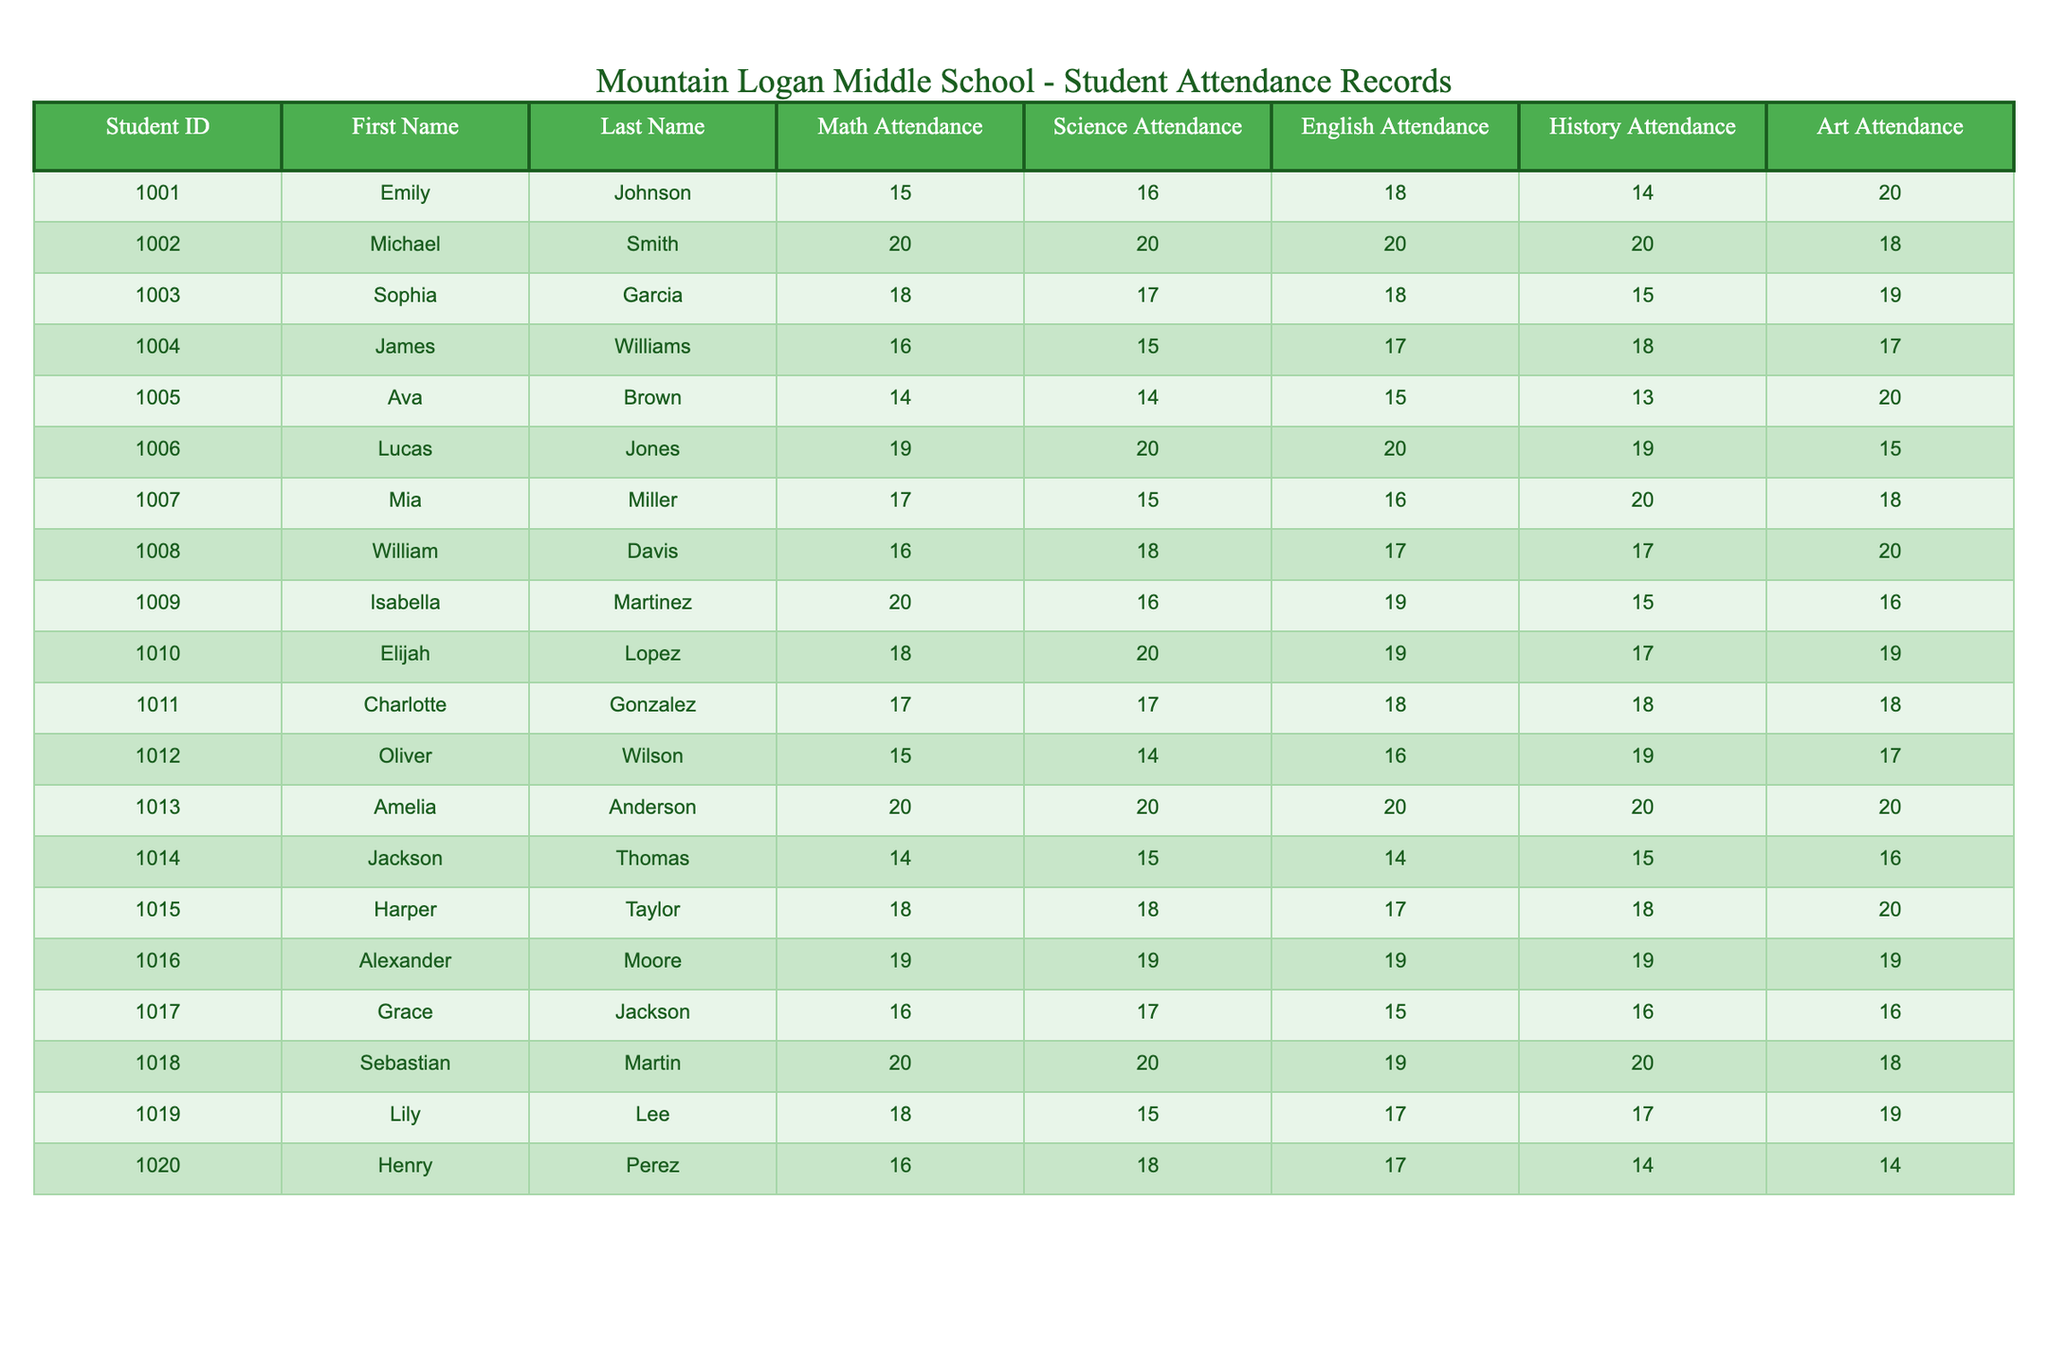What is the total attendance of Emily Johnson in all subjects? Emily Johnson's attendance in Math is 15, Science is 16, English is 18, History is 14, and Art is 20. Adding these values together gives us 15 + 16 + 18 + 14 + 20 = 83.
Answer: 83 Which student has the highest attendance in Art? By examining the Art Attendance column, we see the following values: 20, 18, 19, and so on. The highest value is 20, which is achieved by multiple students including Emily Johnson, Lucas Jones, and Amelia Anderson.
Answer: Multiple students (Emily Johnson, Lucas Jones, Amelia Anderson) What is the average Science Attendance of all students? To find the average, we sum the Science Attendance values: 16 + 20 + 17 + 15 + 14 + 20 + 15 + 18 + 16 + 20 + 17 + 14 + 15 + 18 + 19 + 20 + 15 + 20 + 18 + 18 = 323. There are 20 students, so the average is 323 / 20 = 16.15.
Answer: 16.15 Did any student attend all classes (i.e., a perfect attendance of 20)? By checking the attendance in each subject, we find that Amelia Anderson has a perfect attendance of 20 in Math, Science, English, History, and Art. Thus, she is the only one who attended all classes perfectly.
Answer: Yes, Amelia Anderson Which subjects had the lowest average attendance? First, we calculate the average attendance for each subject: Math: (sum of Math Attendance)/20 = 16.45, Science: 17.15, English: 17.10, History: 17.05, Art: 17.45. The lowest average attendance is found in English with an average of 17.10.
Answer: English How many students have an attendance lower than 15 in Math? By looking through the Math Attendance column, we identify the students with values below 15: Ava Brown's 14 and Jackson Thomas's 14. This totals to 2 students.
Answer: 2 Which subject had the highest overall attendance when summed across all students? Math totals to 328, Science to 323, English to 340, History to 336, and Art to 355. The highest overall attendance is in Art with a total of 355.
Answer: Art What is the attendance difference between the highest and lowest attendee in Science? The highest attendance in Science is 20 (by Michael Smith, Lucas Jones, Amelia Anderson, and others), while the lowest is 14 (by Oliver Wilson). The difference is 20 - 14 = 6.
Answer: 6 How does Mia Miller’s attendance compare across subjects? Mia Miller's attendances are Math: 17, Science: 15, English: 16, History: 20, Art: 18. The highest is 20 in History, while the lowest is 15 in Science.
Answer: Highest: 20 (History), Lowest: 15 (Science) 